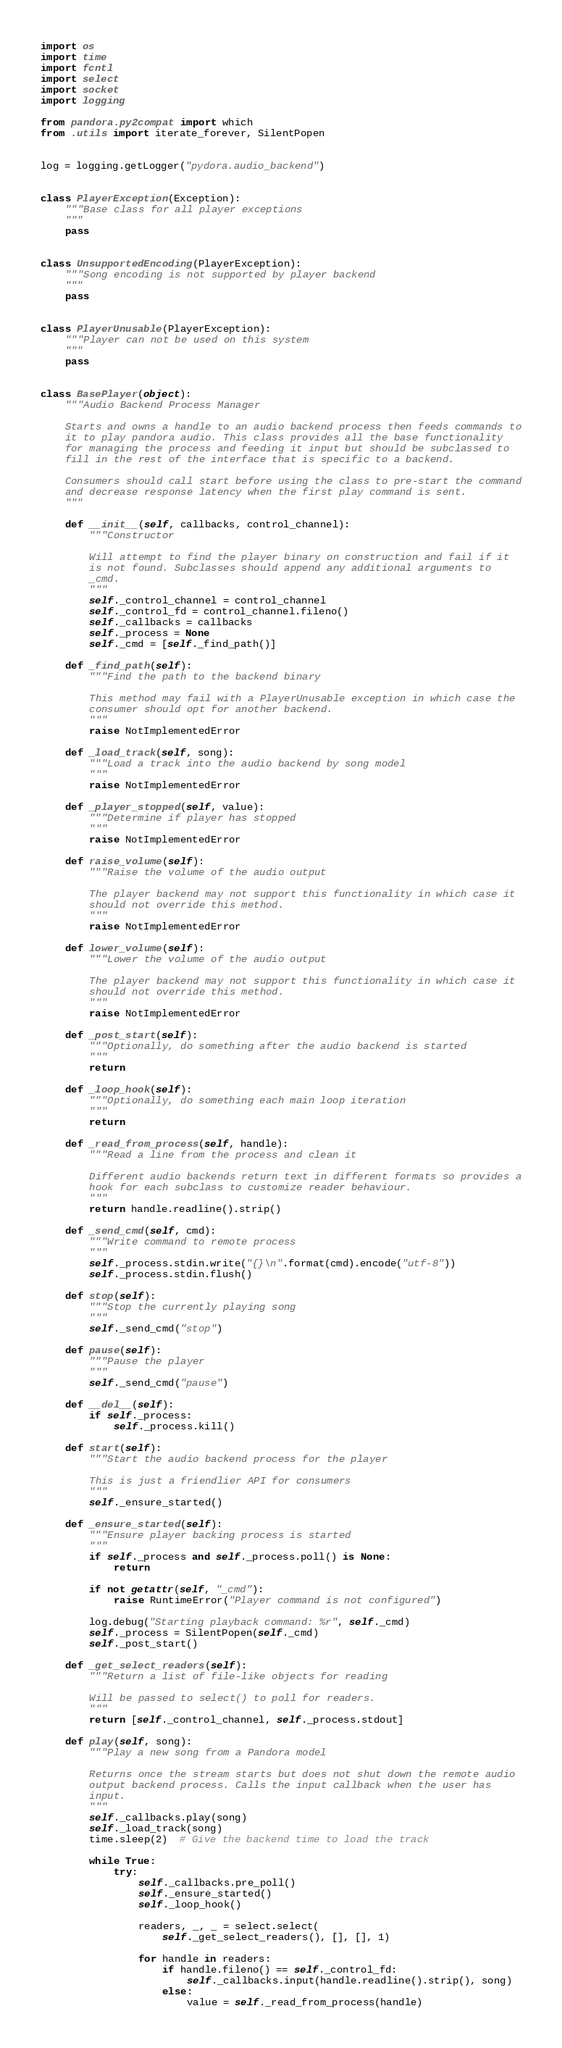Convert code to text. <code><loc_0><loc_0><loc_500><loc_500><_Python_>import os
import time
import fcntl
import select
import socket
import logging

from pandora.py2compat import which
from .utils import iterate_forever, SilentPopen


log = logging.getLogger("pydora.audio_backend")


class PlayerException(Exception):
    """Base class for all player exceptions
    """
    pass


class UnsupportedEncoding(PlayerException):
    """Song encoding is not supported by player backend
    """
    pass


class PlayerUnusable(PlayerException):
    """Player can not be used on this system
    """
    pass


class BasePlayer(object):
    """Audio Backend Process Manager

    Starts and owns a handle to an audio backend process then feeds commands to
    it to play pandora audio. This class provides all the base functionality
    for managing the process and feeding it input but should be subclassed to
    fill in the rest of the interface that is specific to a backend.

    Consumers should call start before using the class to pre-start the command
    and decrease response latency when the first play command is sent.
    """

    def __init__(self, callbacks, control_channel):
        """Constructor

        Will attempt to find the player binary on construction and fail if it
        is not found. Subclasses should append any additional arguments to
        _cmd.
        """
        self._control_channel = control_channel
        self._control_fd = control_channel.fileno()
        self._callbacks = callbacks
        self._process = None
        self._cmd = [self._find_path()]

    def _find_path(self):
        """Find the path to the backend binary

        This method may fail with a PlayerUnusable exception in which case the
        consumer should opt for another backend.
        """
        raise NotImplementedError

    def _load_track(self, song):
        """Load a track into the audio backend by song model
        """
        raise NotImplementedError

    def _player_stopped(self, value):
        """Determine if player has stopped
        """
        raise NotImplementedError

    def raise_volume(self):
        """Raise the volume of the audio output

        The player backend may not support this functionality in which case it
        should not override this method.
        """
        raise NotImplementedError

    def lower_volume(self):
        """Lower the volume of the audio output

        The player backend may not support this functionality in which case it
        should not override this method.
        """
        raise NotImplementedError

    def _post_start(self):
        """Optionally, do something after the audio backend is started
        """
        return

    def _loop_hook(self):
        """Optionally, do something each main loop iteration
        """
        return

    def _read_from_process(self, handle):
        """Read a line from the process and clean it

        Different audio backends return text in different formats so provides a
        hook for each subclass to customize reader behaviour.
        """
        return handle.readline().strip()

    def _send_cmd(self, cmd):
        """Write command to remote process
        """
        self._process.stdin.write("{}\n".format(cmd).encode("utf-8"))
        self._process.stdin.flush()

    def stop(self):
        """Stop the currently playing song
        """
        self._send_cmd("stop")

    def pause(self):
        """Pause the player
        """
        self._send_cmd("pause")

    def __del__(self):
        if self._process:
            self._process.kill()

    def start(self):
        """Start the audio backend process for the player

        This is just a friendlier API for consumers
        """
        self._ensure_started()

    def _ensure_started(self):
        """Ensure player backing process is started
        """
        if self._process and self._process.poll() is None:
            return

        if not getattr(self, "_cmd"):
            raise RuntimeError("Player command is not configured")

        log.debug("Starting playback command: %r", self._cmd)
        self._process = SilentPopen(self._cmd)
        self._post_start()

    def _get_select_readers(self):
        """Return a list of file-like objects for reading

        Will be passed to select() to poll for readers.
        """
        return [self._control_channel, self._process.stdout]

    def play(self, song):
        """Play a new song from a Pandora model

        Returns once the stream starts but does not shut down the remote audio
        output backend process. Calls the input callback when the user has
        input.
        """
        self._callbacks.play(song)
        self._load_track(song)
        time.sleep(2)  # Give the backend time to load the track

        while True:
            try:
                self._callbacks.pre_poll()
                self._ensure_started()
                self._loop_hook()

                readers, _, _ = select.select(
                    self._get_select_readers(), [], [], 1)

                for handle in readers:
                    if handle.fileno() == self._control_fd:
                        self._callbacks.input(handle.readline().strip(), song)
                    else:
                        value = self._read_from_process(handle)</code> 